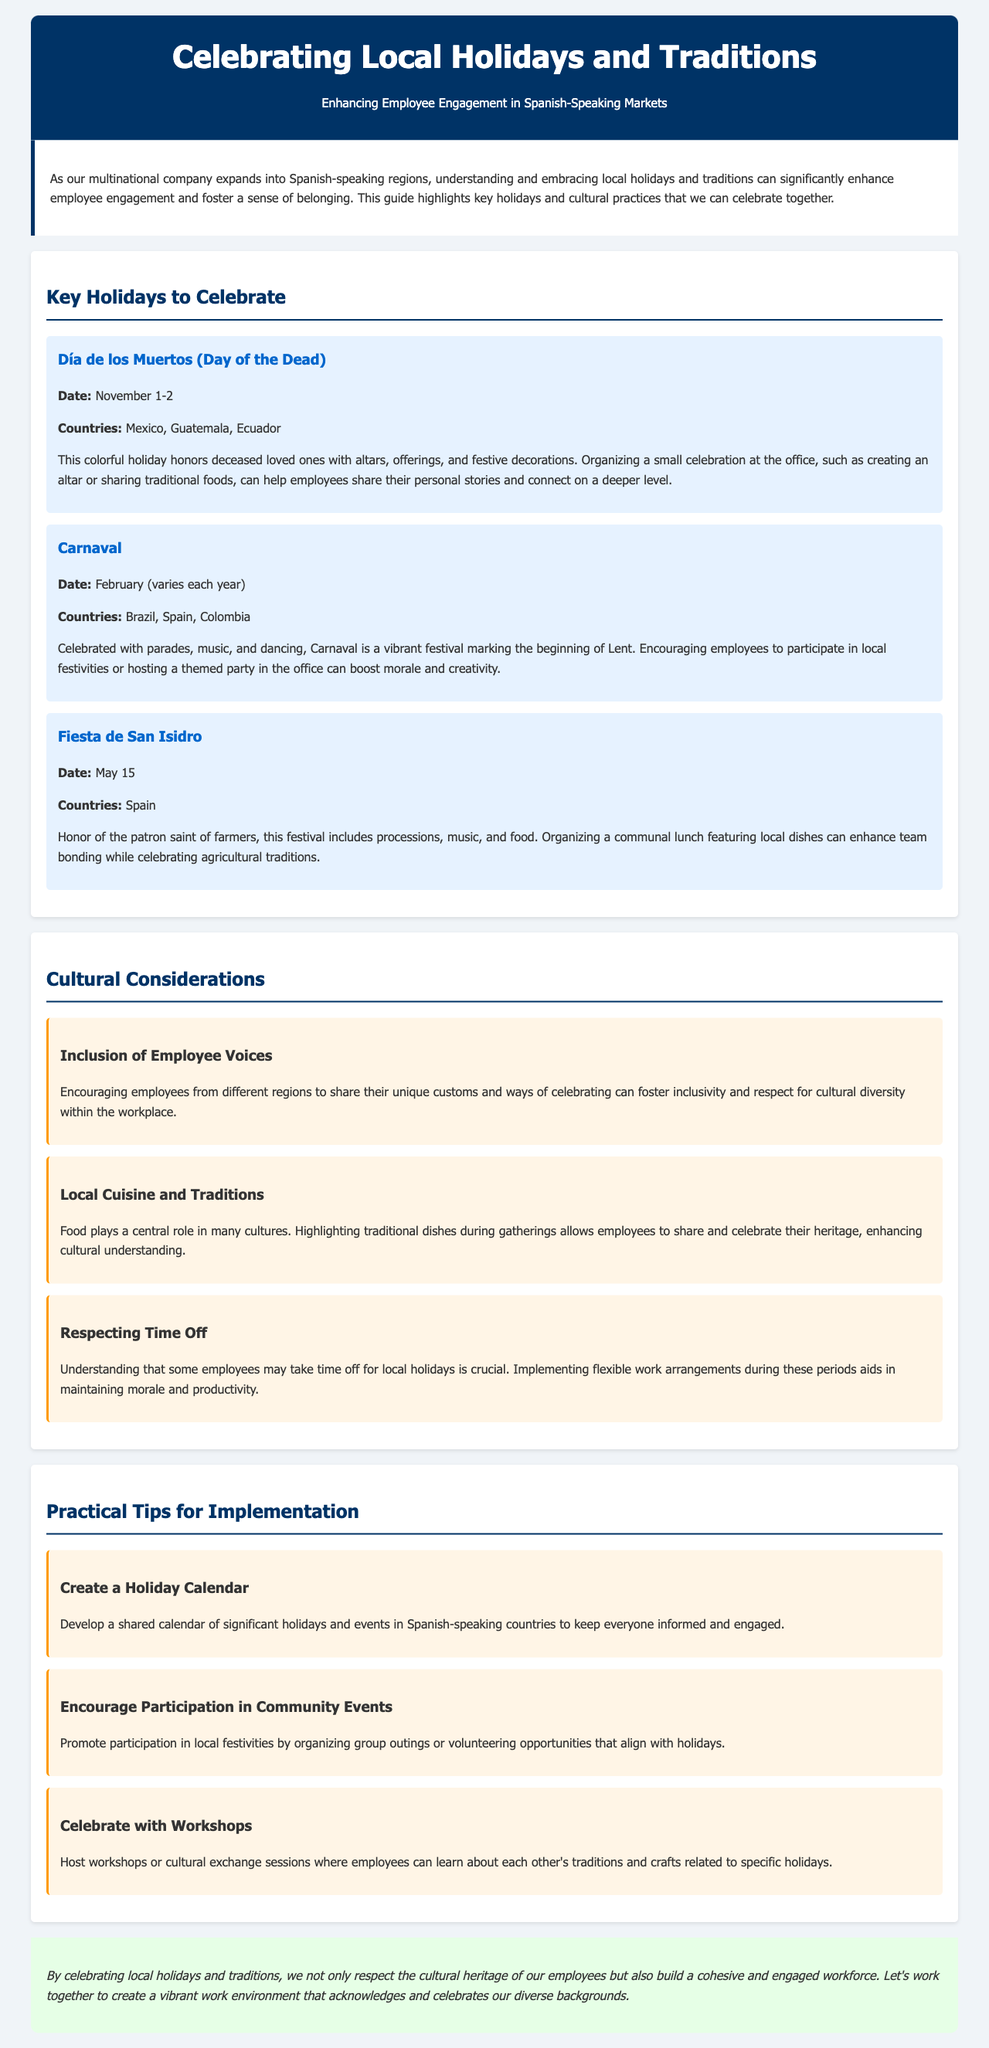What are the dates for Día de los Muertos? The date for Día de los Muertos is specified in the document as November 1-2.
Answer: November 1-2 Which countries celebrate Carnaval? The document lists Brazil, Spain, and Colombia as the countries that celebrate Carnaval.
Answer: Brazil, Spain, Colombia What does the Fiesta de San Isidro honor? The Fiesta de San Isidro honors the patron saint of farmers, as mentioned in the document.
Answer: The patron saint of farmers What is a key cultural consideration mentioned in the document? The document notes the encouragement of employees from different regions to share their unique customs to foster inclusivity.
Answer: Inclusion of Employee Voices What is one practical tip for celebrating local holidays? The document suggests creating a shared holiday calendar to keep everyone informed and engaged.
Answer: Create a Holiday Calendar How does celebrating local holidays impact employee engagement? The document states that celebrating local holidays builds a cohesive and engaged workforce.
Answer: Builds a cohesive and engaged workforce What is a suggested activity for community involvement during local festivities? The document encourages promoting participation in local festivities by organizing group outings or volunteering opportunities.
Answer: Organizing group outings Which holiday is celebrated on May 15? The document specifies that the Fiesta de San Isidro is celebrated on May 15.
Answer: Fiesta de San Isidro What is one way to enhance cultural understanding during gatherings? The document suggests highlighting traditional dishes during gatherings to promote cultural understanding.
Answer: Highlighting traditional dishes 